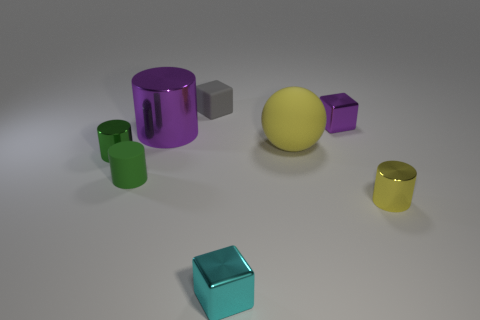Are there fewer yellow rubber objects than large green shiny spheres?
Give a very brief answer. No. Is the size of the cyan block the same as the green thing that is to the left of the rubber cylinder?
Your answer should be very brief. Yes. What color is the tiny rubber object that is in front of the small rubber object that is behind the big ball?
Make the answer very short. Green. How many objects are shiny cylinders that are on the left side of the matte block or tiny objects in front of the small purple metallic thing?
Your answer should be very brief. 5. Do the yellow metal cylinder and the purple cylinder have the same size?
Your answer should be compact. No. Are there any other things that have the same size as the matte cube?
Provide a short and direct response. Yes. There is a thing that is behind the tiny purple object; is it the same shape as the small yellow metallic thing in front of the big yellow object?
Offer a terse response. No. What size is the green metal cylinder?
Your answer should be compact. Small. The purple thing left of the matte thing that is behind the large thing that is to the right of the cyan thing is made of what material?
Give a very brief answer. Metal. How many other objects are the same color as the large ball?
Offer a very short reply. 1. 